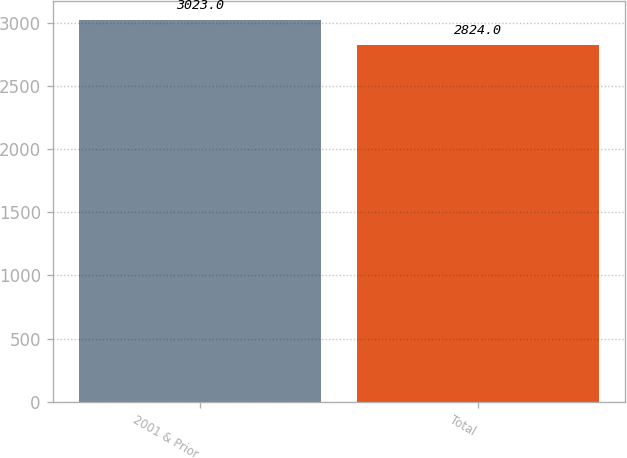Convert chart to OTSL. <chart><loc_0><loc_0><loc_500><loc_500><bar_chart><fcel>2001 & Prior<fcel>Total<nl><fcel>3023<fcel>2824<nl></chart> 